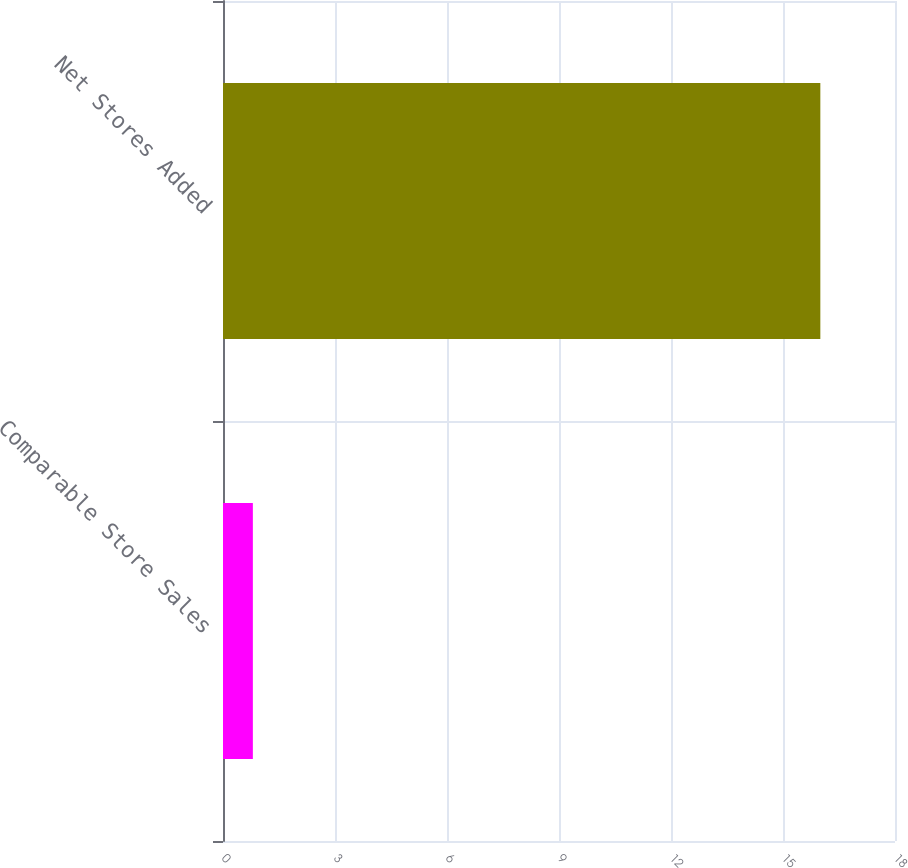Convert chart to OTSL. <chart><loc_0><loc_0><loc_500><loc_500><bar_chart><fcel>Comparable Store Sales<fcel>Net Stores Added<nl><fcel>0.8<fcel>16<nl></chart> 